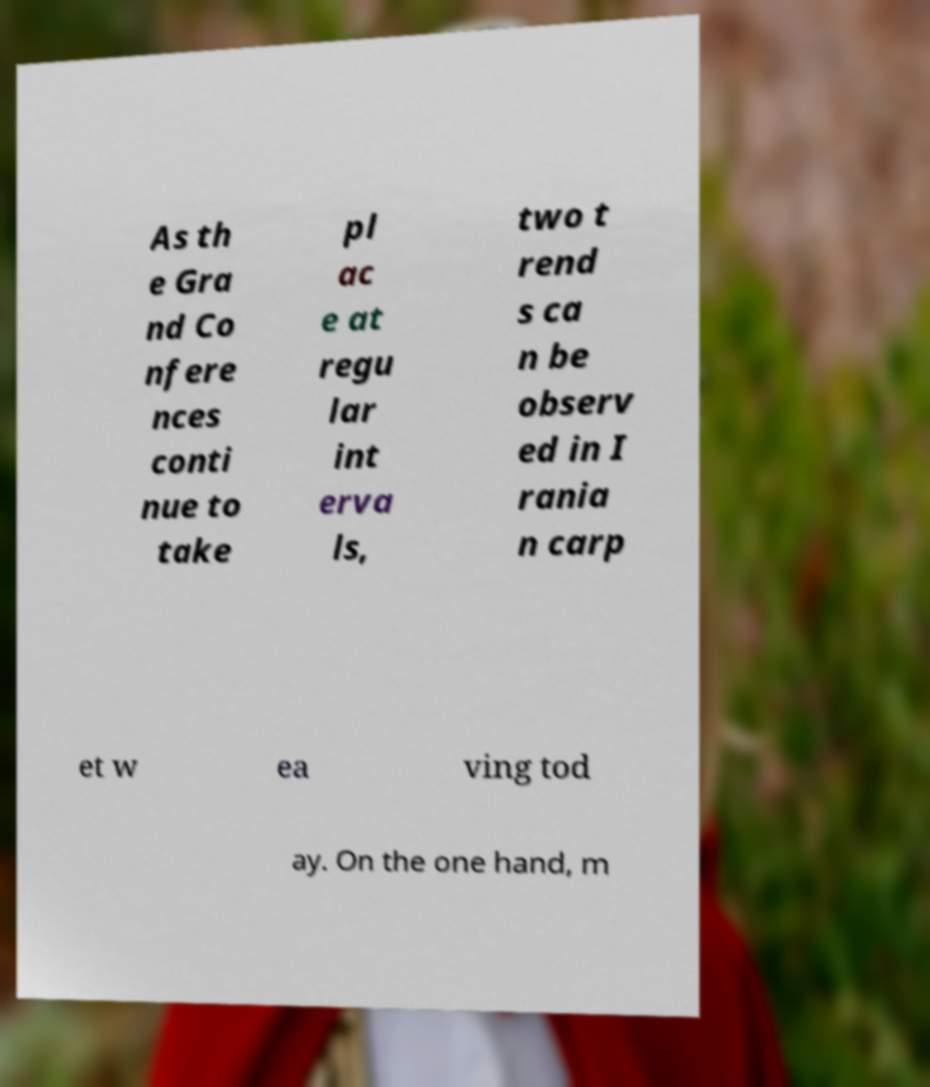Could you extract and type out the text from this image? As th e Gra nd Co nfere nces conti nue to take pl ac e at regu lar int erva ls, two t rend s ca n be observ ed in I rania n carp et w ea ving tod ay. On the one hand, m 